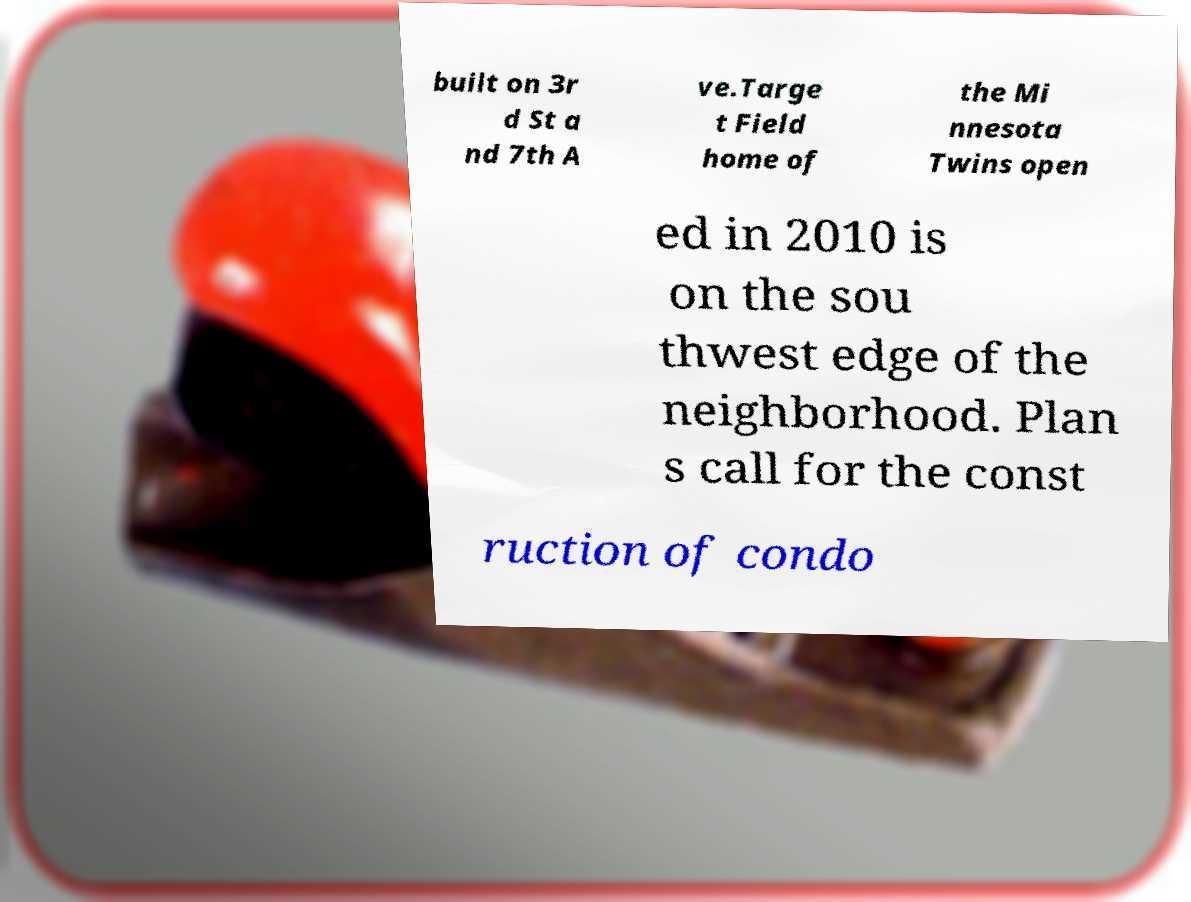There's text embedded in this image that I need extracted. Can you transcribe it verbatim? built on 3r d St a nd 7th A ve.Targe t Field home of the Mi nnesota Twins open ed in 2010 is on the sou thwest edge of the neighborhood. Plan s call for the const ruction of condo 